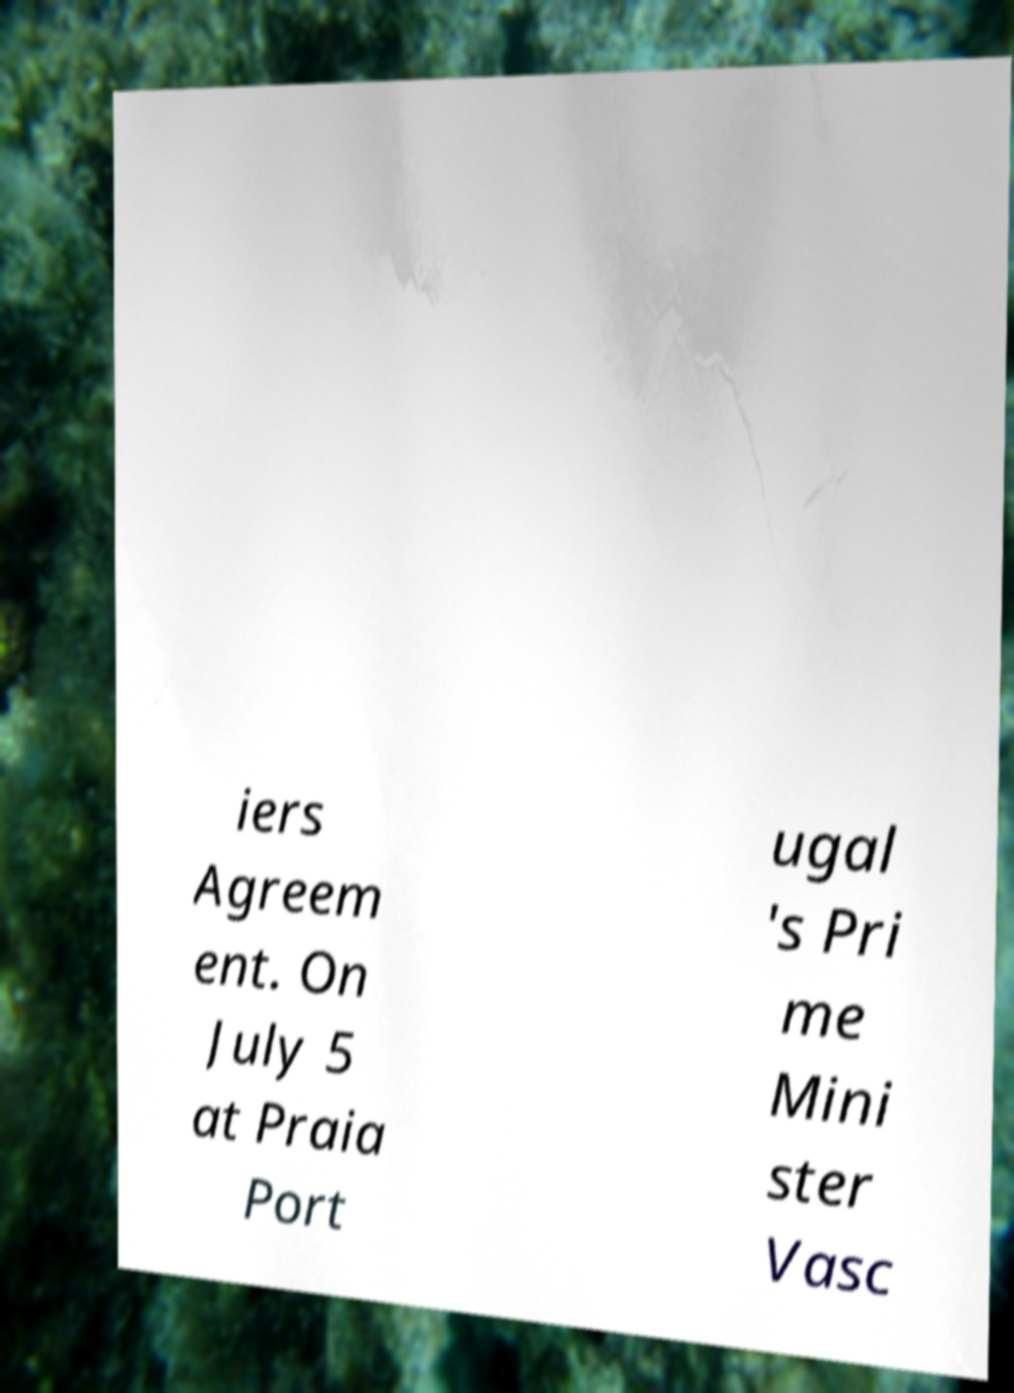Can you accurately transcribe the text from the provided image for me? iers Agreem ent. On July 5 at Praia Port ugal 's Pri me Mini ster Vasc 